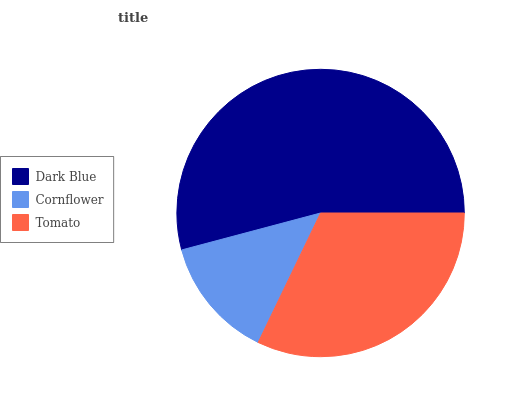Is Cornflower the minimum?
Answer yes or no. Yes. Is Dark Blue the maximum?
Answer yes or no. Yes. Is Tomato the minimum?
Answer yes or no. No. Is Tomato the maximum?
Answer yes or no. No. Is Tomato greater than Cornflower?
Answer yes or no. Yes. Is Cornflower less than Tomato?
Answer yes or no. Yes. Is Cornflower greater than Tomato?
Answer yes or no. No. Is Tomato less than Cornflower?
Answer yes or no. No. Is Tomato the high median?
Answer yes or no. Yes. Is Tomato the low median?
Answer yes or no. Yes. Is Cornflower the high median?
Answer yes or no. No. Is Dark Blue the low median?
Answer yes or no. No. 